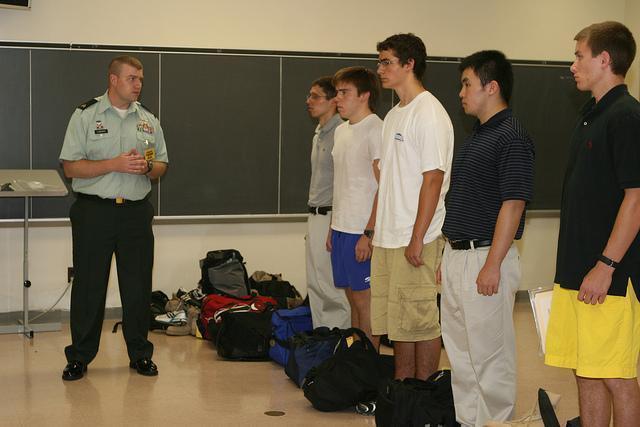What role are persons out of uniform here in?
Select the accurate response from the four choices given to answer the question.
Options: Captains, life guards, recruits, prisoners. Recruits. 